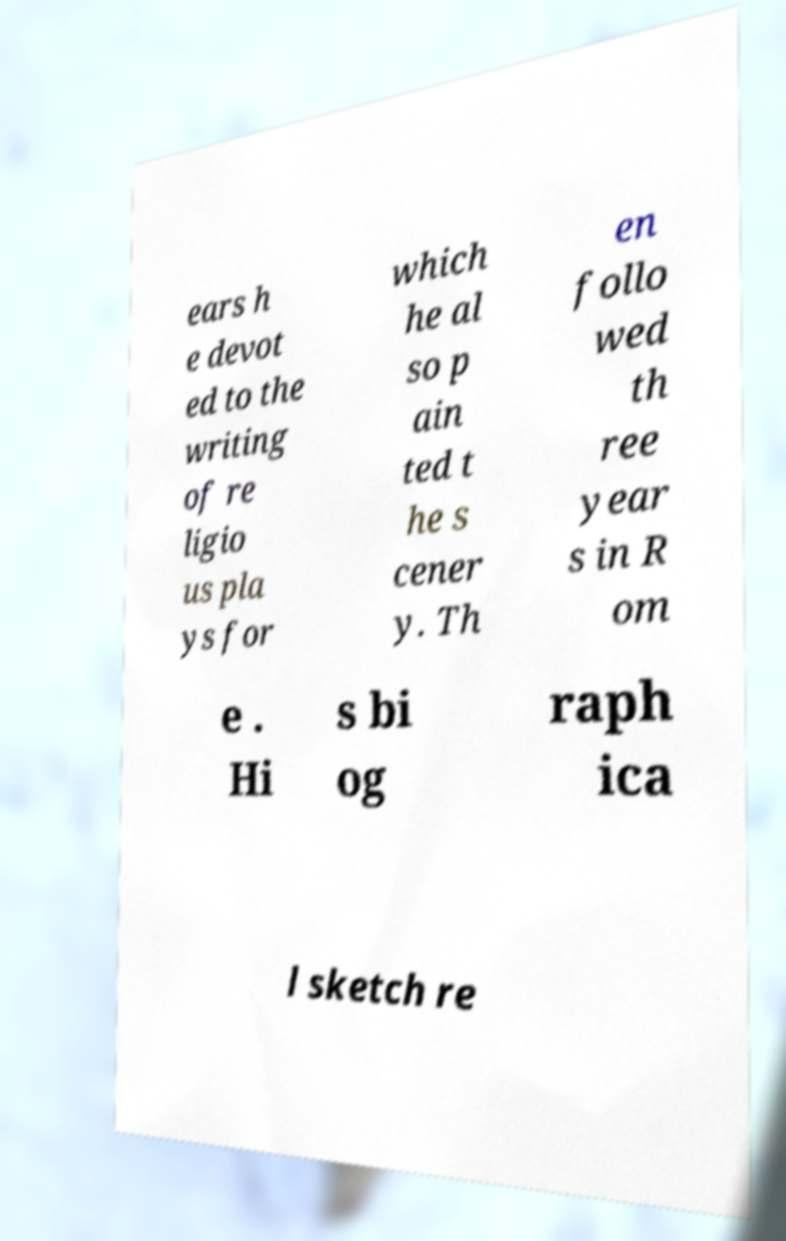Could you extract and type out the text from this image? ears h e devot ed to the writing of re ligio us pla ys for which he al so p ain ted t he s cener y. Th en follo wed th ree year s in R om e . Hi s bi og raph ica l sketch re 